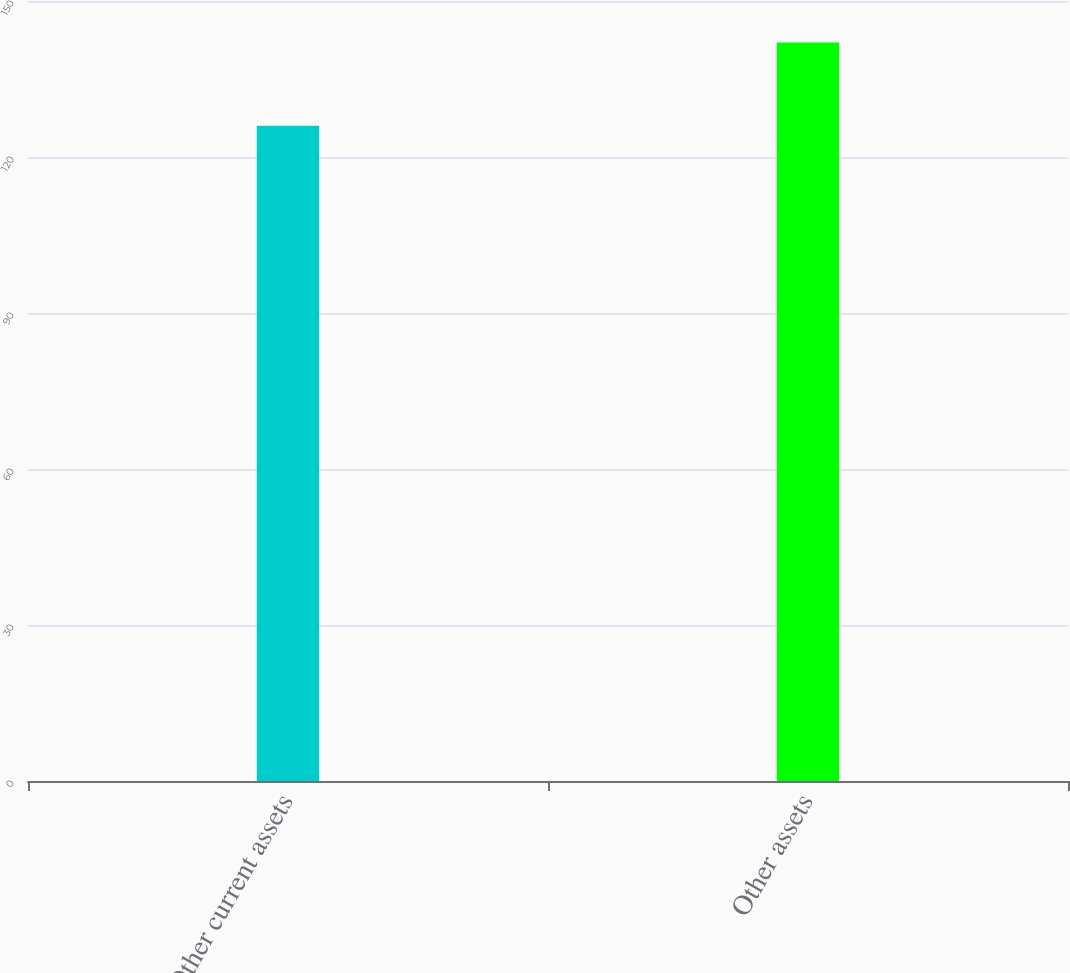Convert chart to OTSL. <chart><loc_0><loc_0><loc_500><loc_500><bar_chart><fcel>Other current assets<fcel>Other assets<nl><fcel>126<fcel>142<nl></chart> 